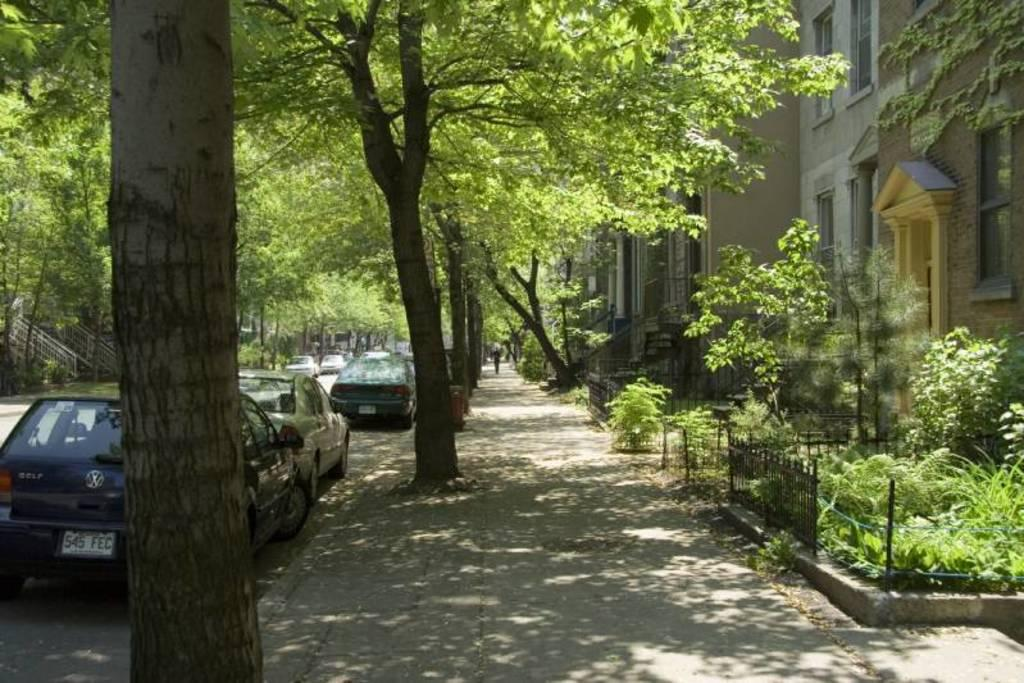What type of structures can be seen in the image? There are buildings in the image. What natural elements are present in the image? There are trees and plants in the image. What type of barrier can be seen in the image? There is a fencing in the image. What type of vehicles are visible in the image? There are cars in the image. What type of rhythm does the uncle play in the image? There is no uncle or rhythm present in the image. How many dimes can be seen on the ground in the image? There are no dimes visible in the image. 